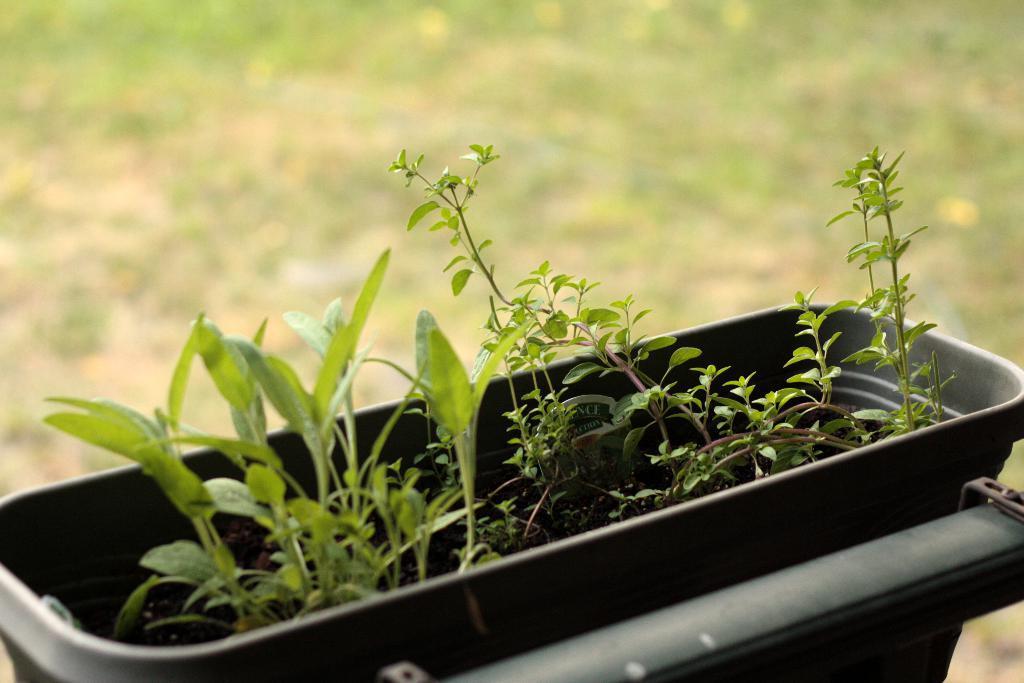Could you give a brief overview of what you see in this image? At the bottom of this image, there is a basket having plants. This basket is attached to an object. And the background is blurred. 